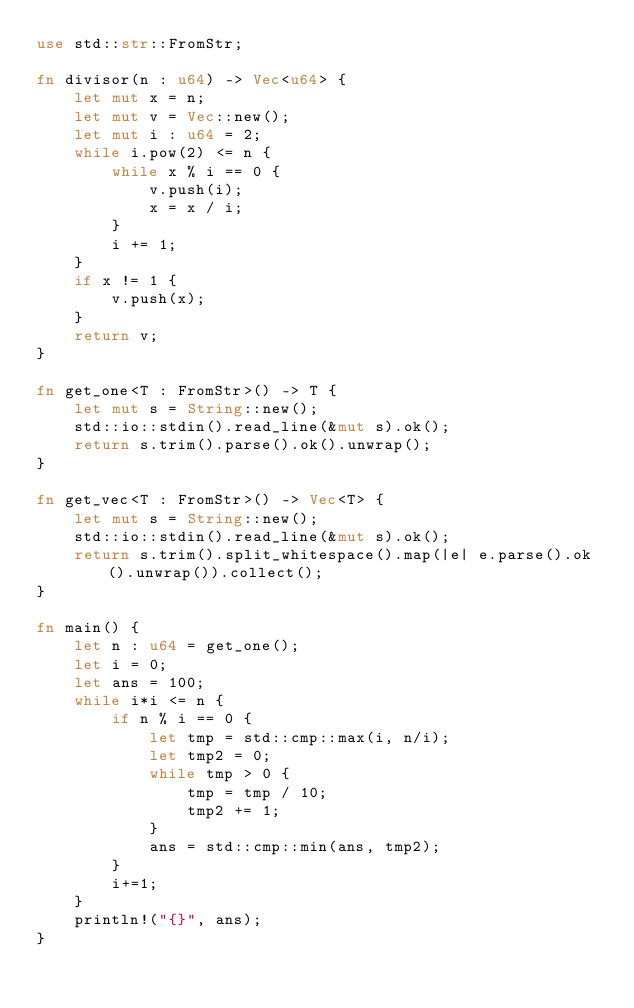Convert code to text. <code><loc_0><loc_0><loc_500><loc_500><_Rust_>use std::str::FromStr;

fn divisor(n : u64) -> Vec<u64> {
    let mut x = n;
    let mut v = Vec::new();
    let mut i : u64 = 2;
    while i.pow(2) <= n {
        while x % i == 0 {
            v.push(i);
            x = x / i;
        }
        i += 1;
    }
    if x != 1 {
        v.push(x);
    }
    return v;
}

fn get_one<T : FromStr>() -> T {
    let mut s = String::new();
    std::io::stdin().read_line(&mut s).ok();
    return s.trim().parse().ok().unwrap();
}

fn get_vec<T : FromStr>() -> Vec<T> {
    let mut s = String::new();
    std::io::stdin().read_line(&mut s).ok();
    return s.trim().split_whitespace().map(|e| e.parse().ok().unwrap()).collect();
}

fn main() {
    let n : u64 = get_one();
    let i = 0;
    let ans = 100;
    while i*i <= n {
        if n % i == 0 {
            let tmp = std::cmp::max(i, n/i);
            let tmp2 = 0;
            while tmp > 0 {
                tmp = tmp / 10;
                tmp2 += 1;
            }
            ans = std::cmp::min(ans, tmp2);
        }
        i+=1;
    }
    println!("{}", ans);
}
</code> 